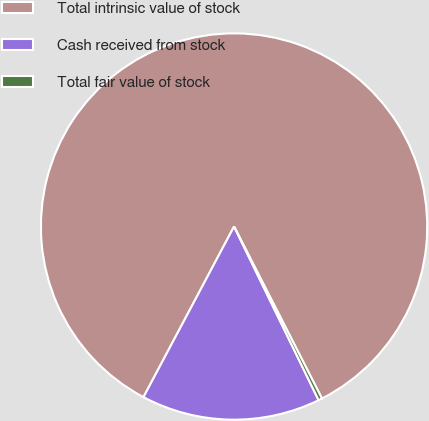Convert chart to OTSL. <chart><loc_0><loc_0><loc_500><loc_500><pie_chart><fcel>Total intrinsic value of stock<fcel>Cash received from stock<fcel>Total fair value of stock<nl><fcel>84.71%<fcel>14.98%<fcel>0.31%<nl></chart> 